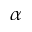<formula> <loc_0><loc_0><loc_500><loc_500>\alpha</formula> 